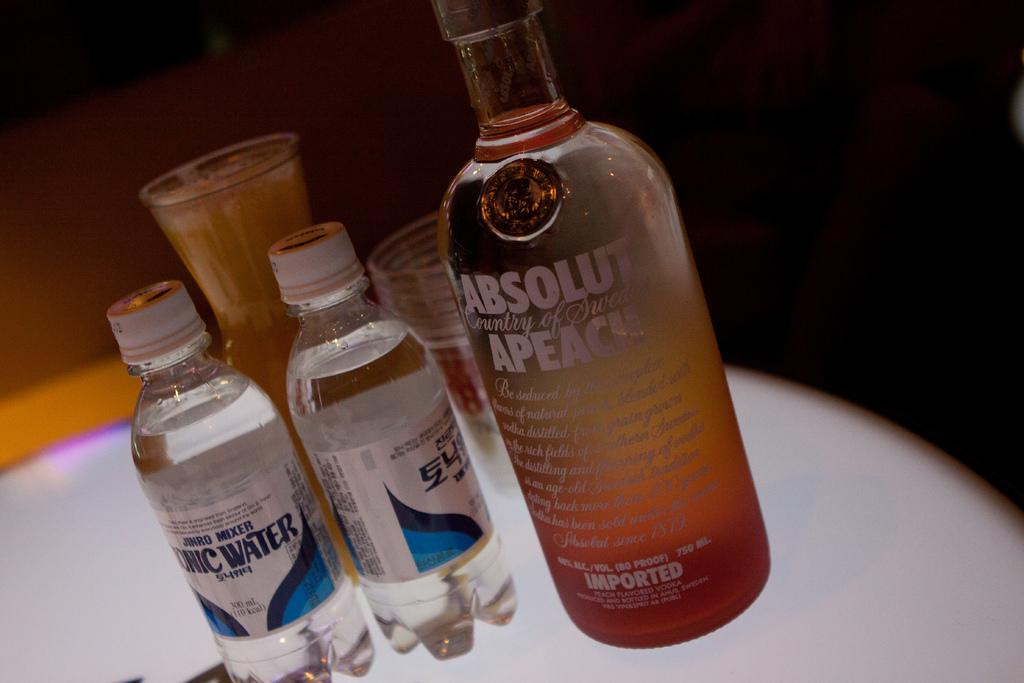<image>
Create a compact narrative representing the image presented. A bottle of Absolute brand vodka is on a table with other bottles. 